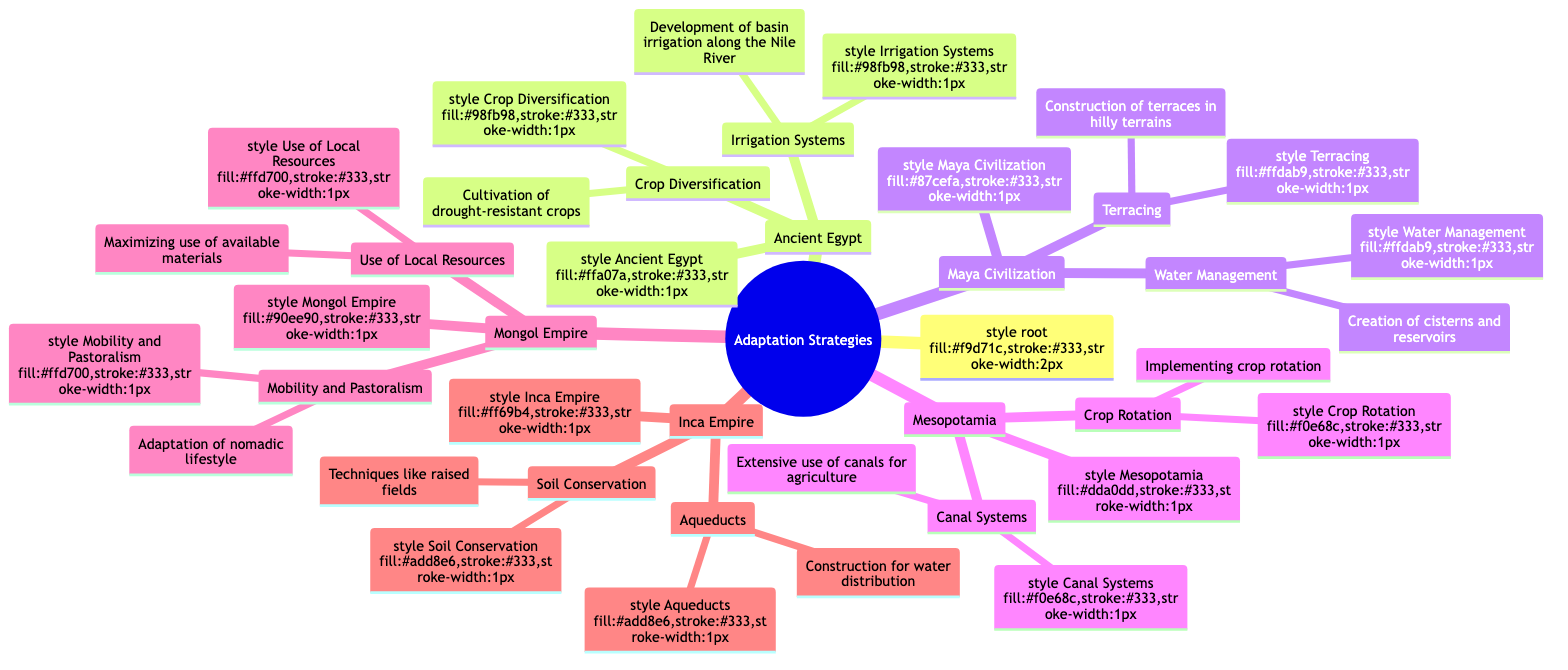What is a key adaptation strategy used by the Inca Empire? The Inca Empire is noted for two main adaptation strategies: soil conservation techniques and construction of aqueducts. Among these, soil conservation stands out as a key strategy due to its importance in preventing soil degradation.
Answer: Soil Conservation How many civilizations are represented in the adaptation strategies? The diagram lists five distinct civilizations: Ancient Egypt, Maya Civilization, Mesopotamia, Mongol Empire, and Inca Empire. Counting each civilization yields a total of five.
Answer: 5 What specific method was used by the Maya Civilization to manage water? The diagram highlights that the Maya Civilization implemented water management through the creation of cisterns and reservoirs. This explicit detail directly addresses the method used for water management.
Answer: Creation of cisterns and reservoirs Which civilization used extensive canal systems for agriculture? The diagram indicates that Mesopotamia is the civilization that utilized extensive canal systems for agricultural purposes. This straightforward connection can be directly identified within the text.
Answer: Mesopotamia What adaptation strategy involved the nomadic lifestyle in the Mongol Empire? The Mongol Empire adapted through mobility and pastoralism, which involved a nomadic lifestyle tailored to shifting climatic zones. This directly reflects their approach to climatic changes.
Answer: Mobility and Pastoralism Which crop diversification technique did Ancient Egypt utilize? Ancient Egypt practiced crop diversification by cultivating drought-resistant crops, specifically mentioning sorghum and millet. This indicates their focus on resilience in agriculture.
Answer: Cultivation of drought-resistant crops What construction technique did the Inca Empire use for water distribution? The Inca Empire constructed aqueducts for efficient water distribution, illustrating their advanced engineering and management of water resources for adapting to environmental conditions.
Answer: Aqueducts How does crop rotation relate to Mesopotamia? The diagram shows that Mesopotamia implemented crop rotation as a method to maintain soil fertility. This relationship is essential for understanding their agricultural practices in response to climate challenges.
Answer: Implementing crop rotation What topographical adaptation strategy did the Maya Civilization employ? The Maya Civilization employed terracing, which is a construction method utilized in hilly terrains to mitigate soil erosion. This geographical strategy is crucial for adapting to their environment.
Answer: Construction of terraces 